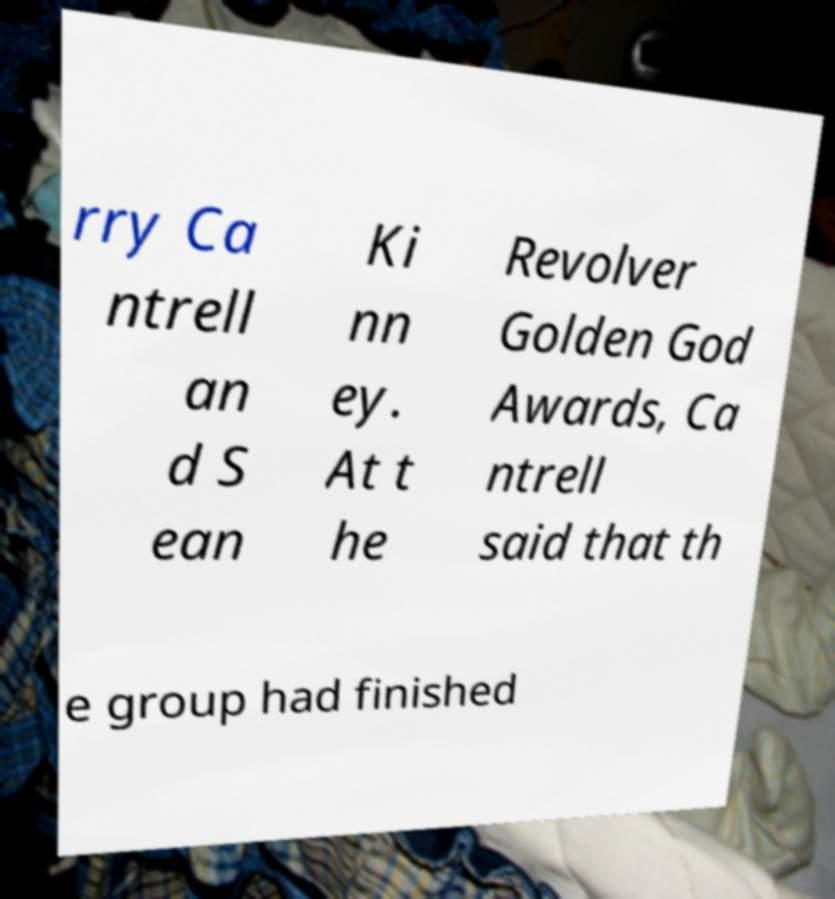What messages or text are displayed in this image? I need them in a readable, typed format. rry Ca ntrell an d S ean Ki nn ey. At t he Revolver Golden God Awards, Ca ntrell said that th e group had finished 